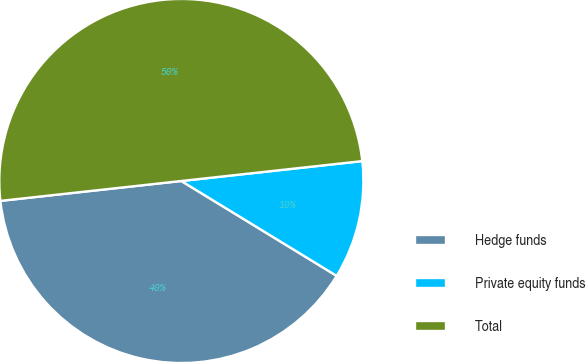<chart> <loc_0><loc_0><loc_500><loc_500><pie_chart><fcel>Hedge funds<fcel>Private equity funds<fcel>Total<nl><fcel>39.53%<fcel>10.47%<fcel>50.0%<nl></chart> 